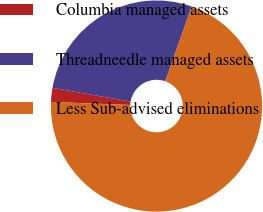Convert chart to OTSL. <chart><loc_0><loc_0><loc_500><loc_500><pie_chart><fcel>Columbia managed assets<fcel>Threadneedle managed assets<fcel>Less Sub-advised eliminations<nl><fcel>2.13%<fcel>27.66%<fcel>70.21%<nl></chart> 